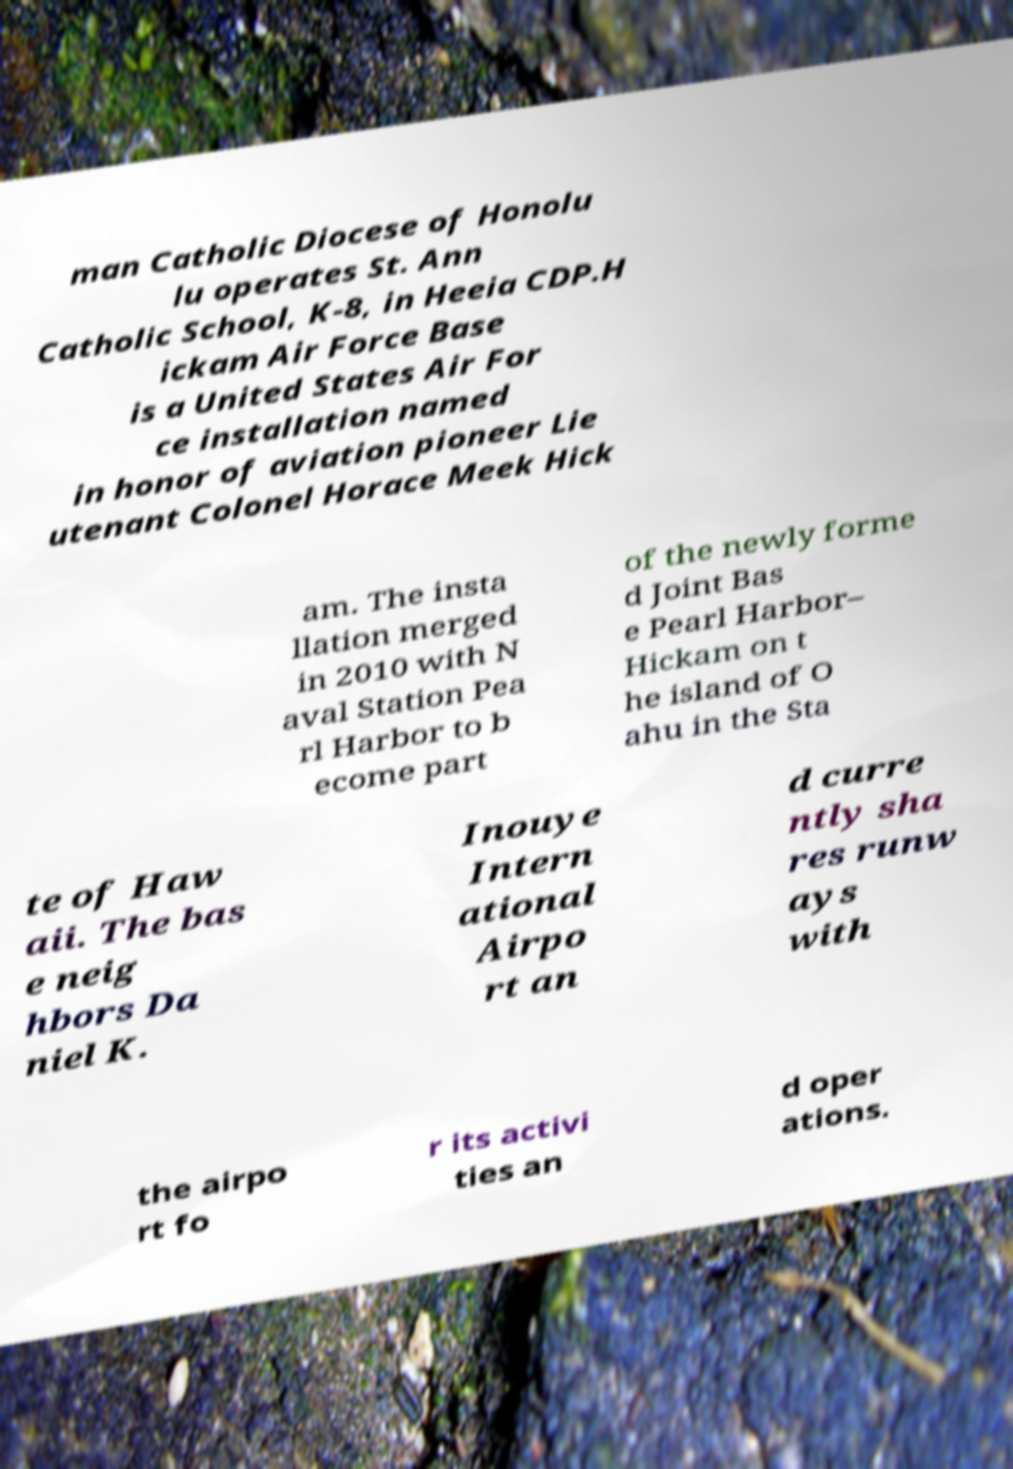I need the written content from this picture converted into text. Can you do that? man Catholic Diocese of Honolu lu operates St. Ann Catholic School, K-8, in Heeia CDP.H ickam Air Force Base is a United States Air For ce installation named in honor of aviation pioneer Lie utenant Colonel Horace Meek Hick am. The insta llation merged in 2010 with N aval Station Pea rl Harbor to b ecome part of the newly forme d Joint Bas e Pearl Harbor– Hickam on t he island of O ahu in the Sta te of Haw aii. The bas e neig hbors Da niel K. Inouye Intern ational Airpo rt an d curre ntly sha res runw ays with the airpo rt fo r its activi ties an d oper ations. 